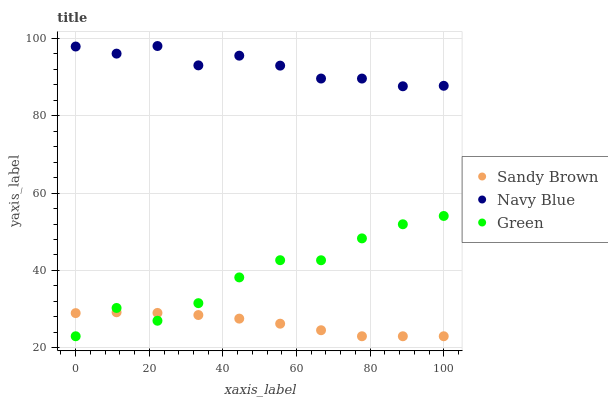Does Sandy Brown have the minimum area under the curve?
Answer yes or no. Yes. Does Navy Blue have the maximum area under the curve?
Answer yes or no. Yes. Does Green have the minimum area under the curve?
Answer yes or no. No. Does Green have the maximum area under the curve?
Answer yes or no. No. Is Sandy Brown the smoothest?
Answer yes or no. Yes. Is Green the roughest?
Answer yes or no. Yes. Is Green the smoothest?
Answer yes or no. No. Is Sandy Brown the roughest?
Answer yes or no. No. Does Green have the lowest value?
Answer yes or no. Yes. Does Navy Blue have the highest value?
Answer yes or no. Yes. Does Green have the highest value?
Answer yes or no. No. Is Green less than Navy Blue?
Answer yes or no. Yes. Is Navy Blue greater than Sandy Brown?
Answer yes or no. Yes. Does Green intersect Sandy Brown?
Answer yes or no. Yes. Is Green less than Sandy Brown?
Answer yes or no. No. Is Green greater than Sandy Brown?
Answer yes or no. No. Does Green intersect Navy Blue?
Answer yes or no. No. 